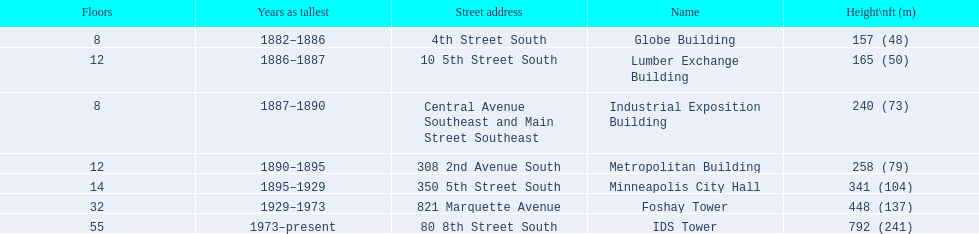Could you parse the entire table? {'header': ['Floors', 'Years as tallest', 'Street address', 'Name', 'Height\\nft (m)'], 'rows': [['8', '1882–1886', '4th Street South', 'Globe Building', '157 (48)'], ['12', '1886–1887', '10 5th Street South', 'Lumber Exchange Building', '165 (50)'], ['8', '1887–1890', 'Central Avenue Southeast and Main Street Southeast', 'Industrial Exposition Building', '240 (73)'], ['12', '1890–1895', '308 2nd Avenue South', 'Metropolitan Building', '258 (79)'], ['14', '1895–1929', '350 5th Street South', 'Minneapolis City Hall', '341 (104)'], ['32', '1929–1973', '821 Marquette Avenue', 'Foshay Tower', '448 (137)'], ['55', '1973–present', '80 8th Street South', 'IDS Tower', '792 (241)']]} How many floors does the lumber exchange building have? 12. What other building has 12 floors? Metropolitan Building. 